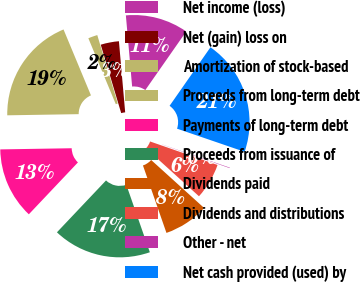Convert chart. <chart><loc_0><loc_0><loc_500><loc_500><pie_chart><fcel>Net income (loss)<fcel>Net (gain) loss on<fcel>Amortization of stock-based<fcel>Proceeds from long-term debt<fcel>Payments of long-term debt<fcel>Proceeds from issuance of<fcel>Dividends paid<fcel>Dividends and distributions<fcel>Other - net<fcel>Net cash provided (used) by<nl><fcel>11.1%<fcel>3.23%<fcel>1.65%<fcel>18.98%<fcel>12.68%<fcel>17.4%<fcel>7.95%<fcel>6.38%<fcel>0.08%<fcel>20.55%<nl></chart> 